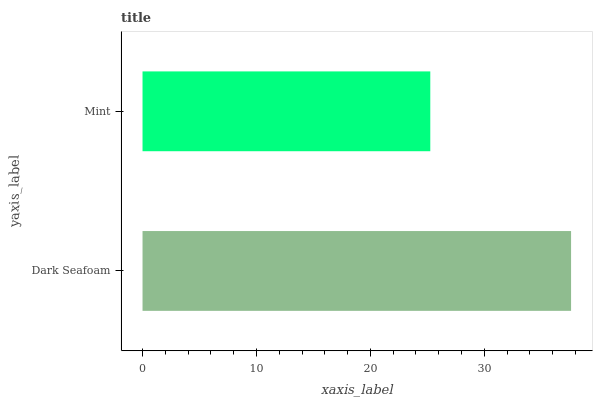Is Mint the minimum?
Answer yes or no. Yes. Is Dark Seafoam the maximum?
Answer yes or no. Yes. Is Mint the maximum?
Answer yes or no. No. Is Dark Seafoam greater than Mint?
Answer yes or no. Yes. Is Mint less than Dark Seafoam?
Answer yes or no. Yes. Is Mint greater than Dark Seafoam?
Answer yes or no. No. Is Dark Seafoam less than Mint?
Answer yes or no. No. Is Dark Seafoam the high median?
Answer yes or no. Yes. Is Mint the low median?
Answer yes or no. Yes. Is Mint the high median?
Answer yes or no. No. Is Dark Seafoam the low median?
Answer yes or no. No. 